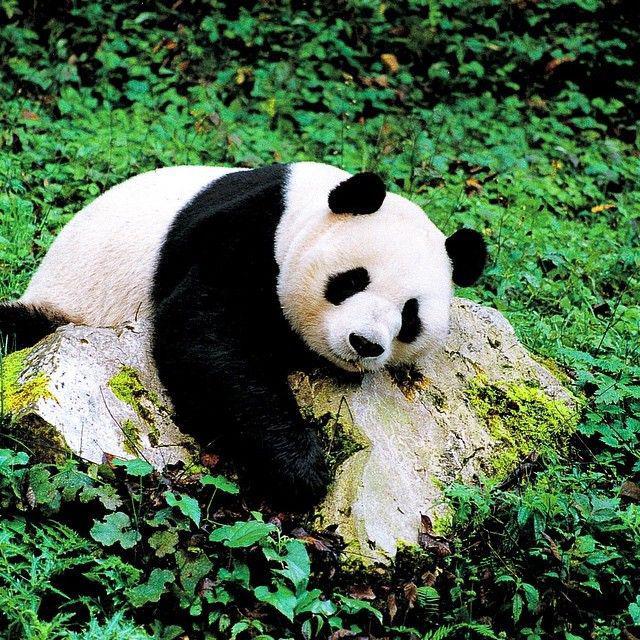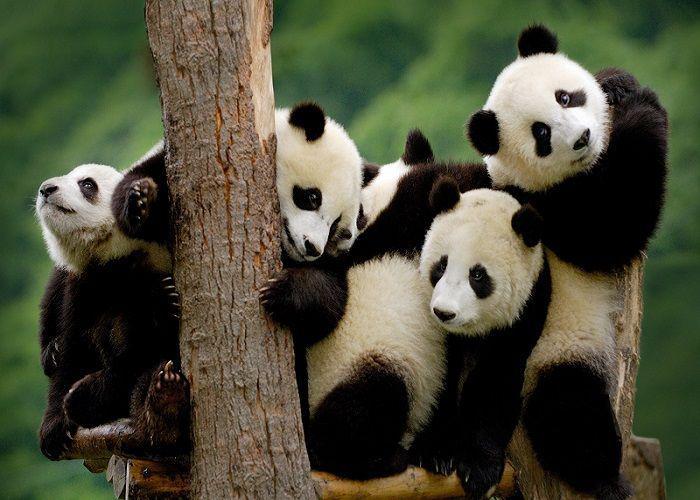The first image is the image on the left, the second image is the image on the right. Analyze the images presented: Is the assertion "there is at least one panda in a tree in the image pair" valid? Answer yes or no. Yes. 